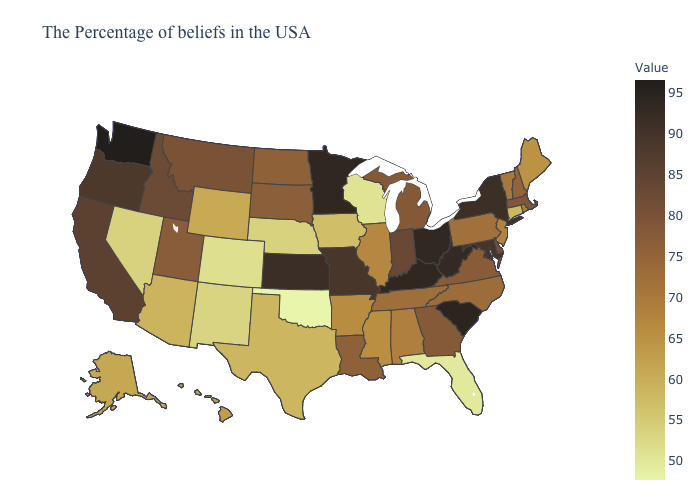Among the states that border Wyoming , which have the highest value?
Concise answer only. Idaho. 